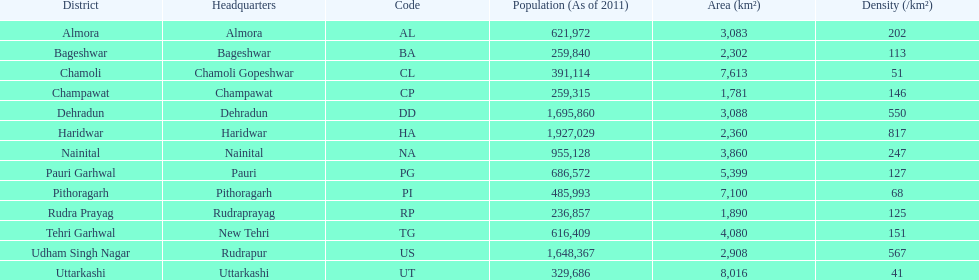Tell me the number of districts with an area over 5000. 4. 